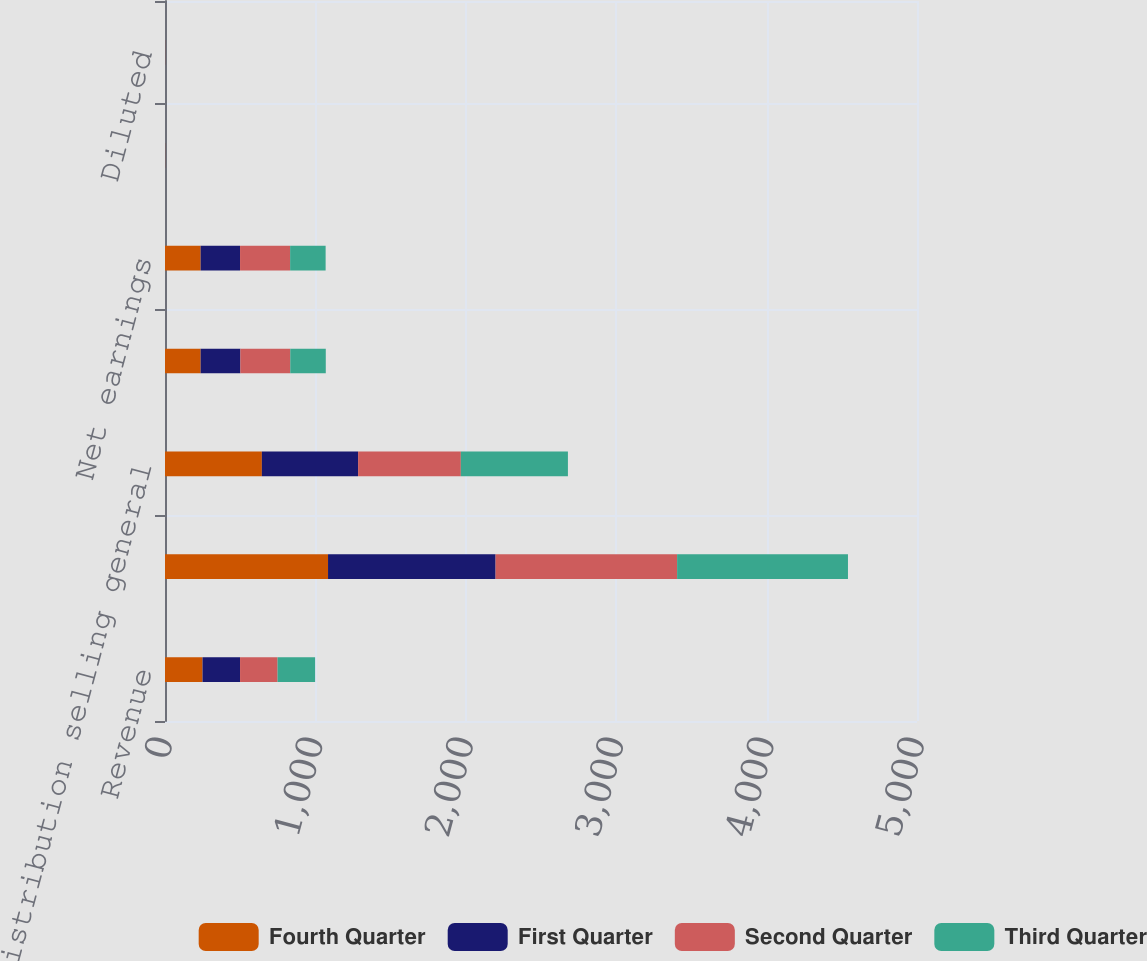Convert chart. <chart><loc_0><loc_0><loc_500><loc_500><stacked_bar_chart><ecel><fcel>Revenue<fcel>Gross margin<fcel>Distribution selling general<fcel>Earnings from continuing<fcel>Net earnings<fcel>Basic<fcel>Diluted<nl><fcel>Fourth Quarter<fcel>249.5<fcel>1084<fcel>644<fcel>237<fcel>237<fcel>0.69<fcel>0.68<nl><fcel>First Quarter<fcel>249.5<fcel>1114<fcel>640<fcel>264<fcel>262<fcel>0.77<fcel>0.76<nl><fcel>Second Quarter<fcel>249.5<fcel>1207<fcel>683<fcel>332<fcel>333<fcel>0.96<fcel>0.95<nl><fcel>Third Quarter<fcel>249.5<fcel>1136<fcel>712<fcel>236<fcel>236<fcel>0.68<fcel>0.68<nl></chart> 